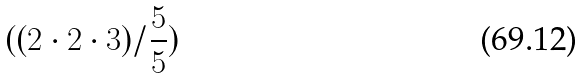<formula> <loc_0><loc_0><loc_500><loc_500>( ( 2 \cdot 2 \cdot 3 ) / \frac { 5 } { 5 } )</formula> 